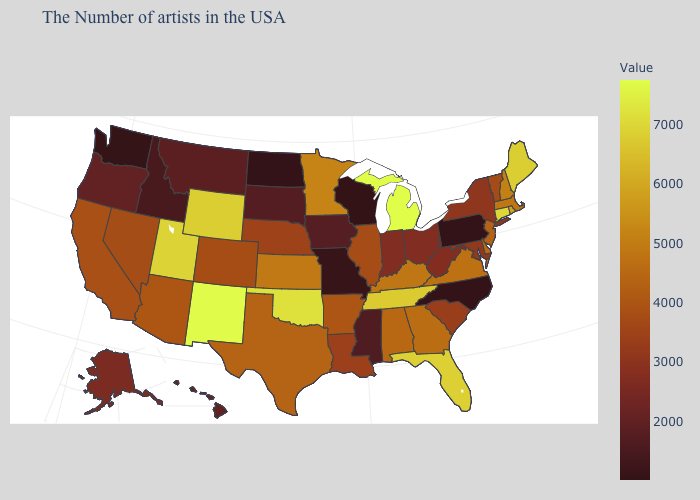Among the states that border Wyoming , which have the highest value?
Write a very short answer. Utah. Among the states that border Missouri , which have the highest value?
Concise answer only. Oklahoma. Among the states that border New Jersey , which have the highest value?
Be succinct. Delaware. Does New Hampshire have the highest value in the Northeast?
Short answer required. No. 